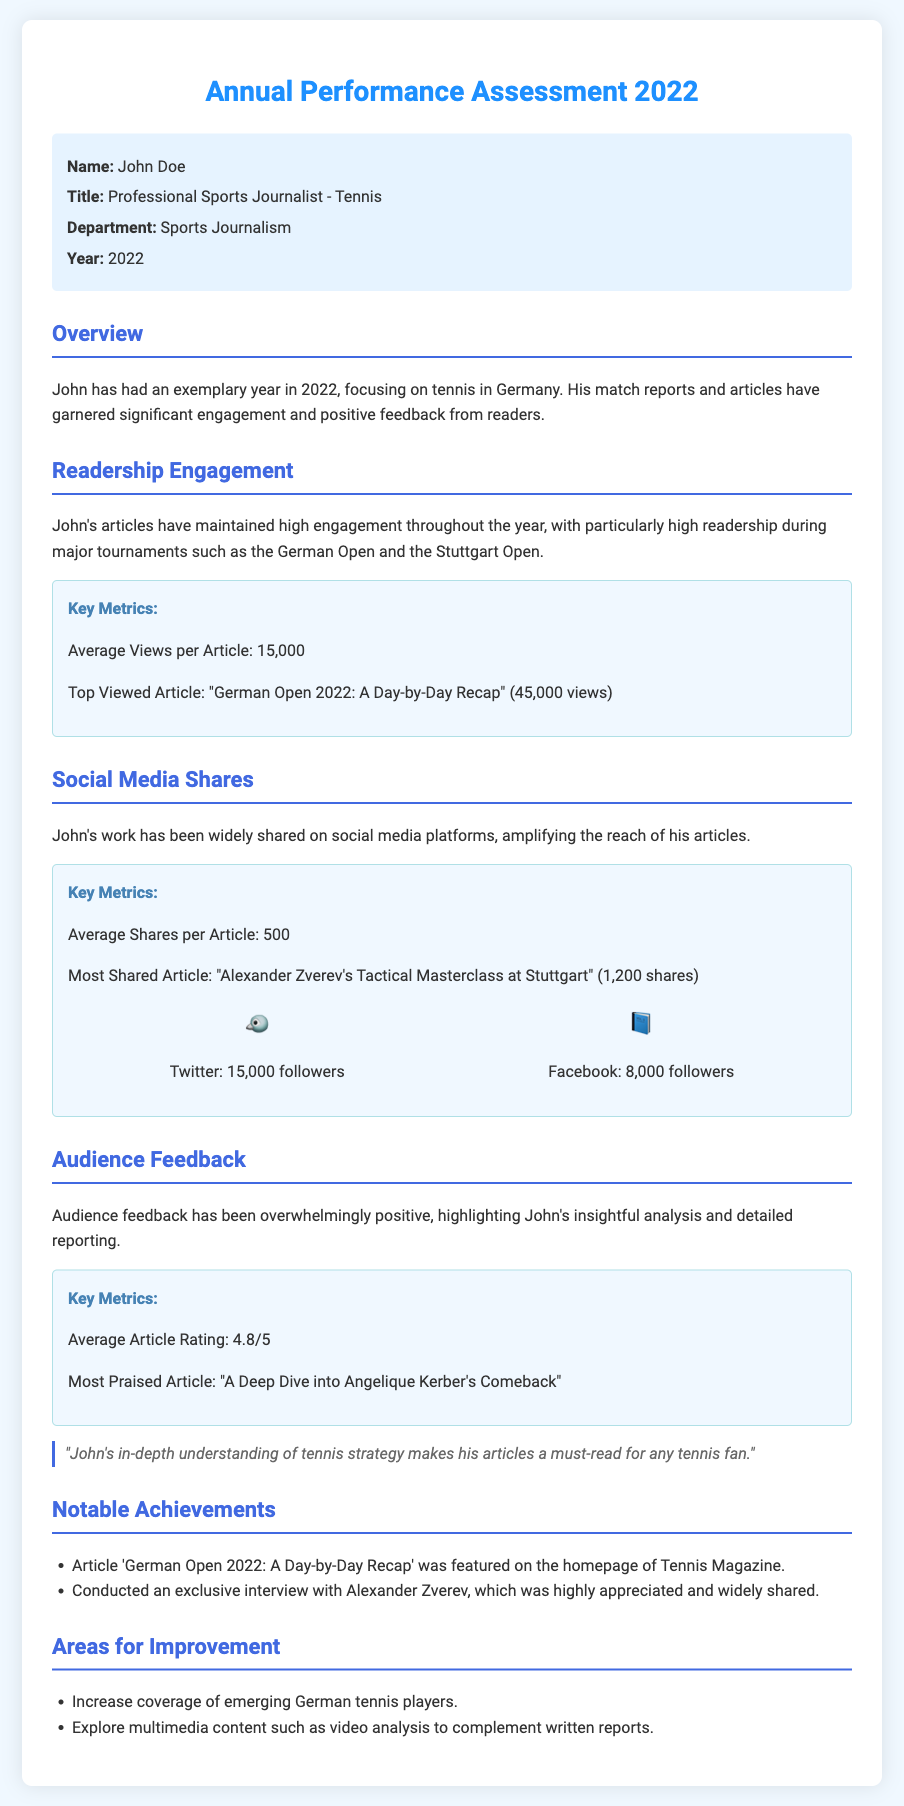What is the name of the journalist? The name of the journalist is provided in the employee info section of the document.
Answer: John Doe What was the average views per article? The average views per article metric is explicitly mentioned in the readership engagement section.
Answer: 15,000 Which article had the most shares? The document specifies the title of the most shared article in the social media shares section.
Answer: "Alexander Zverev's Tactical Masterclass at Stuttgart" What is the average article rating? The average article rating is found in the audience feedback section of the document.
Answer: 4.8/5 What notable achievement was highlighted regarding the German Open article? The notable achievement related to the German Open article is mentioned in the notable achievements section.
Answer: Featured on the homepage of Tennis Magazine What is one area for improvement suggested in the document? Areas for improvement are listed in the respective section, providing potential actions for development.
Answer: Increase coverage of emerging German tennis players How many followers does John have on Twitter? The number of Twitter followers is specified in the social media section of the document.
Answer: 15,000 What was the title of the most praised article? The title is clearly mentioned in the audience feedback section.
Answer: "A Deep Dive into Angelique Kerber's Comeback" 